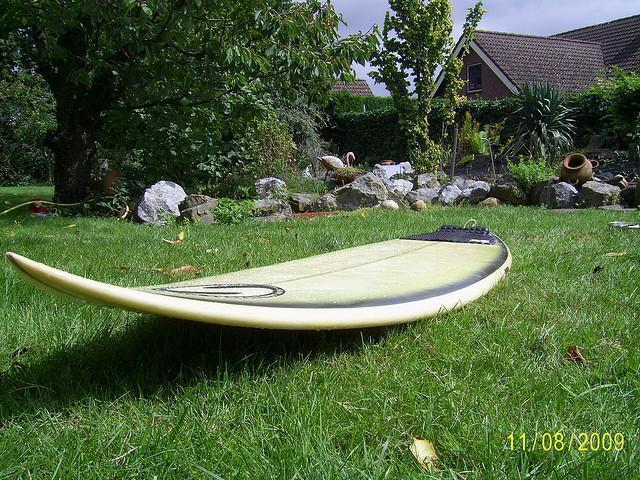How many surfboards are there?
Give a very brief answer. 1. 